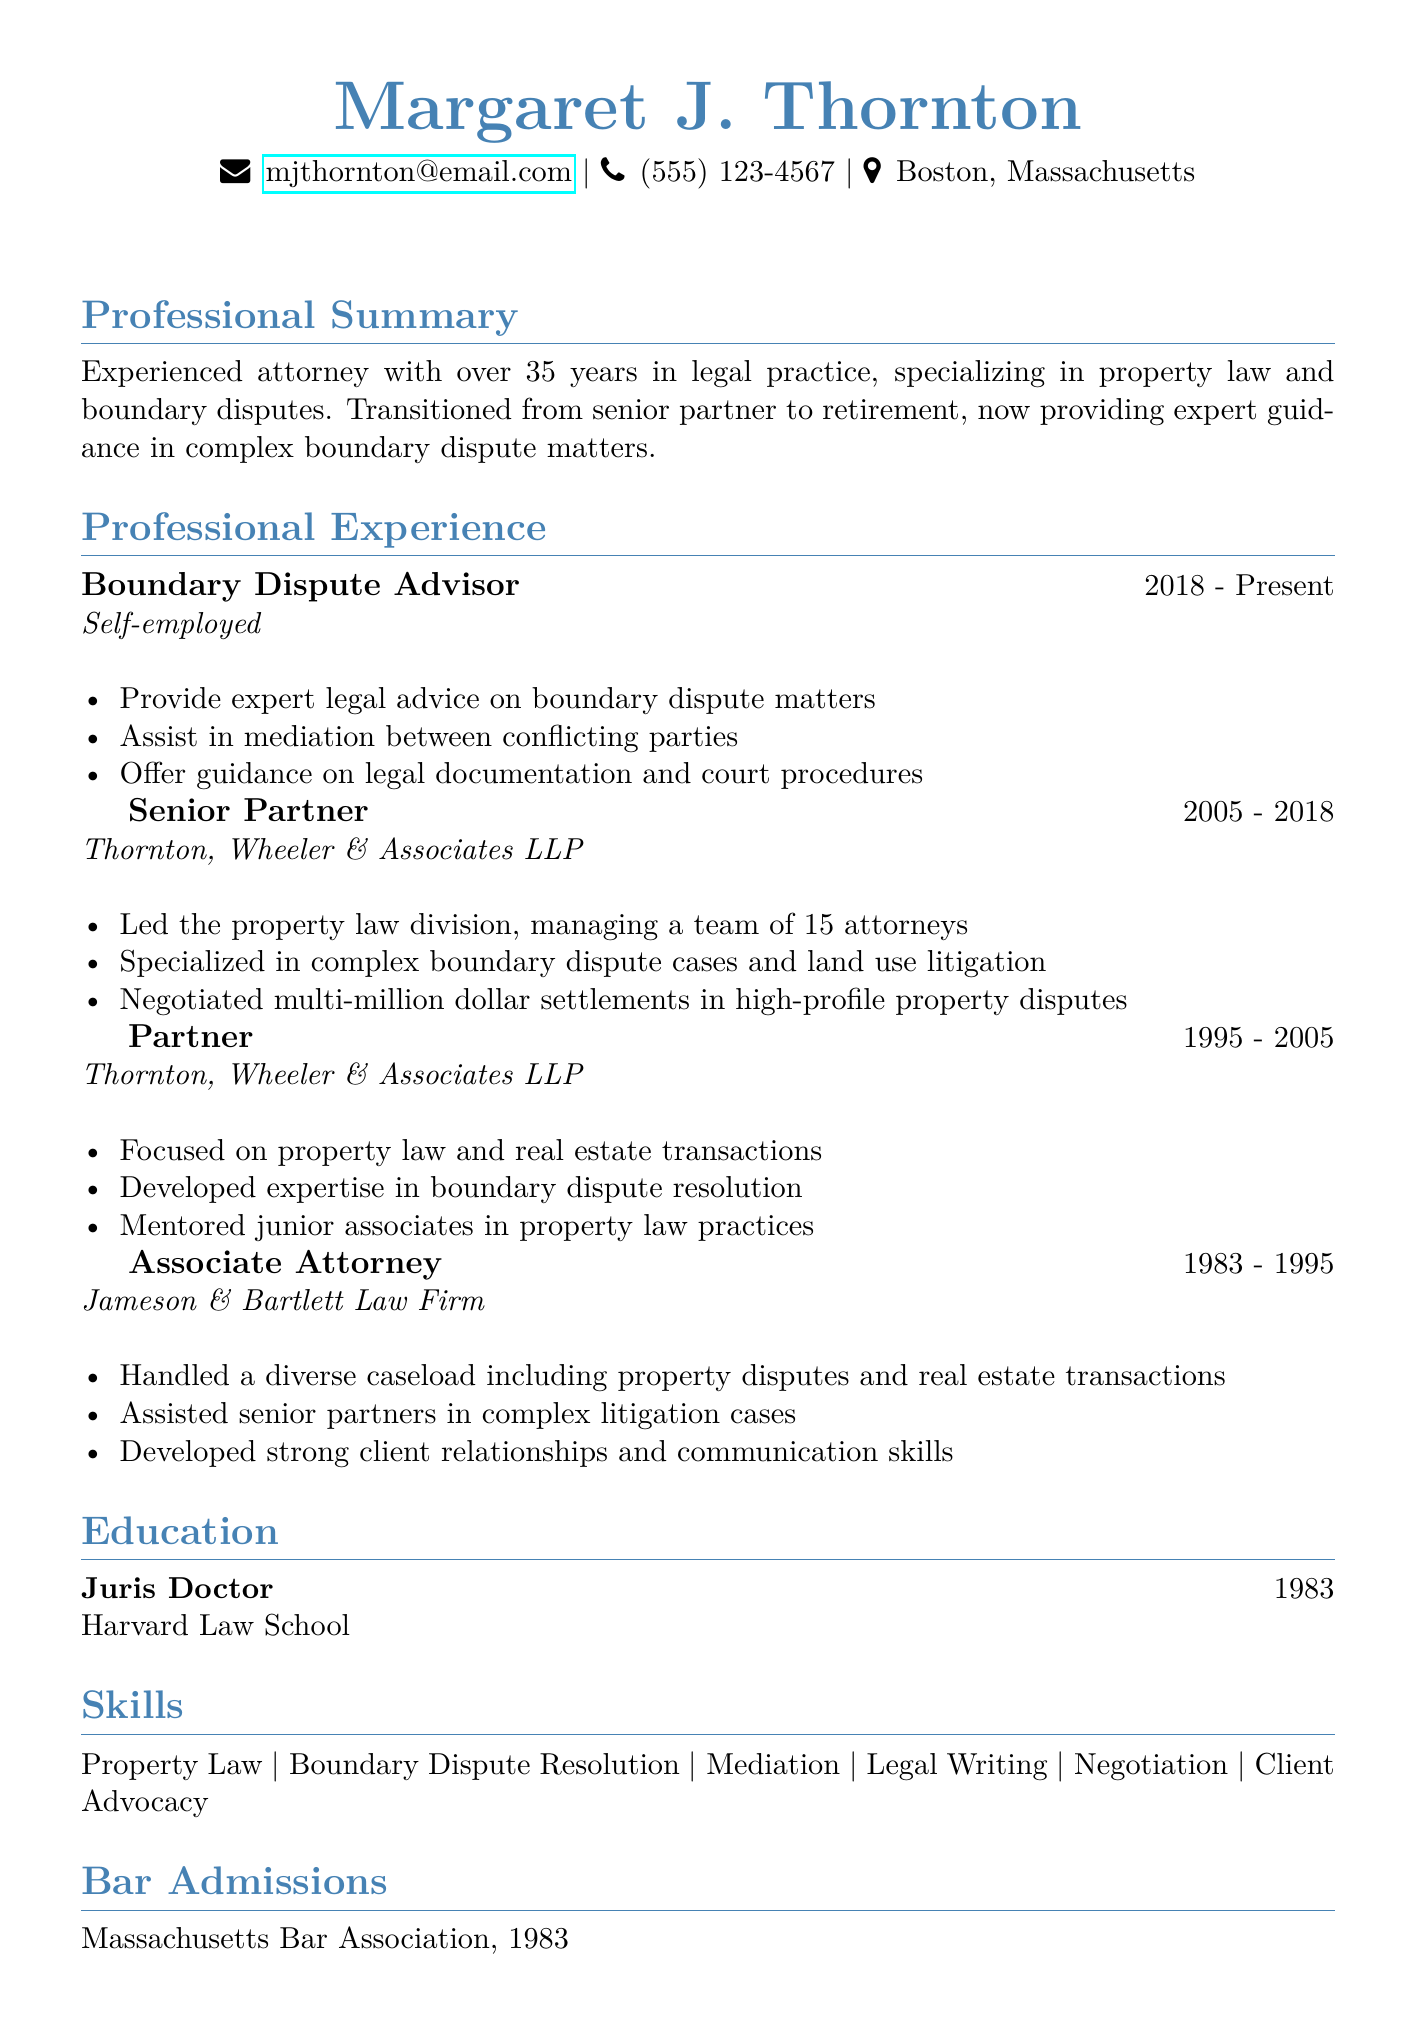What is the name of the advisor? The name of the advisor is stated at the beginning of the document.
Answer: Margaret J. Thornton What is the duration of the role as Senior Partner? The duration is listed in the professional experience section of the document.
Answer: 2005 - 2018 What was the first title mentioned in the experience section? The first title is the earliest position listed in the chronological order.
Answer: Associate Attorney How many attorneys did Margaret manage as a Senior Partner? This number is specified in the responsibilities for the Senior Partner role.
Answer: 15 What law school did Margaret attend? The law school she graduated from is mentioned in the education section.
Answer: Harvard Law School What is the main specialization of Margaret throughout her career? This specialization is highlighted in the professional summary and experience sections.
Answer: Property law In which year was Margaret admitted to the Massachusetts Bar Association? The admission year is clearly listed in the bar admissions section.
Answer: 1983 What is the current professional role of Margaret? This role is described in the professional experience section.
Answer: Boundary Dispute Advisor Which organization is not listed as a professional affiliation? This question asks to identify affiliations from the document.
Answer: Massachusetts Real Estate Bar Association (not in the document) 